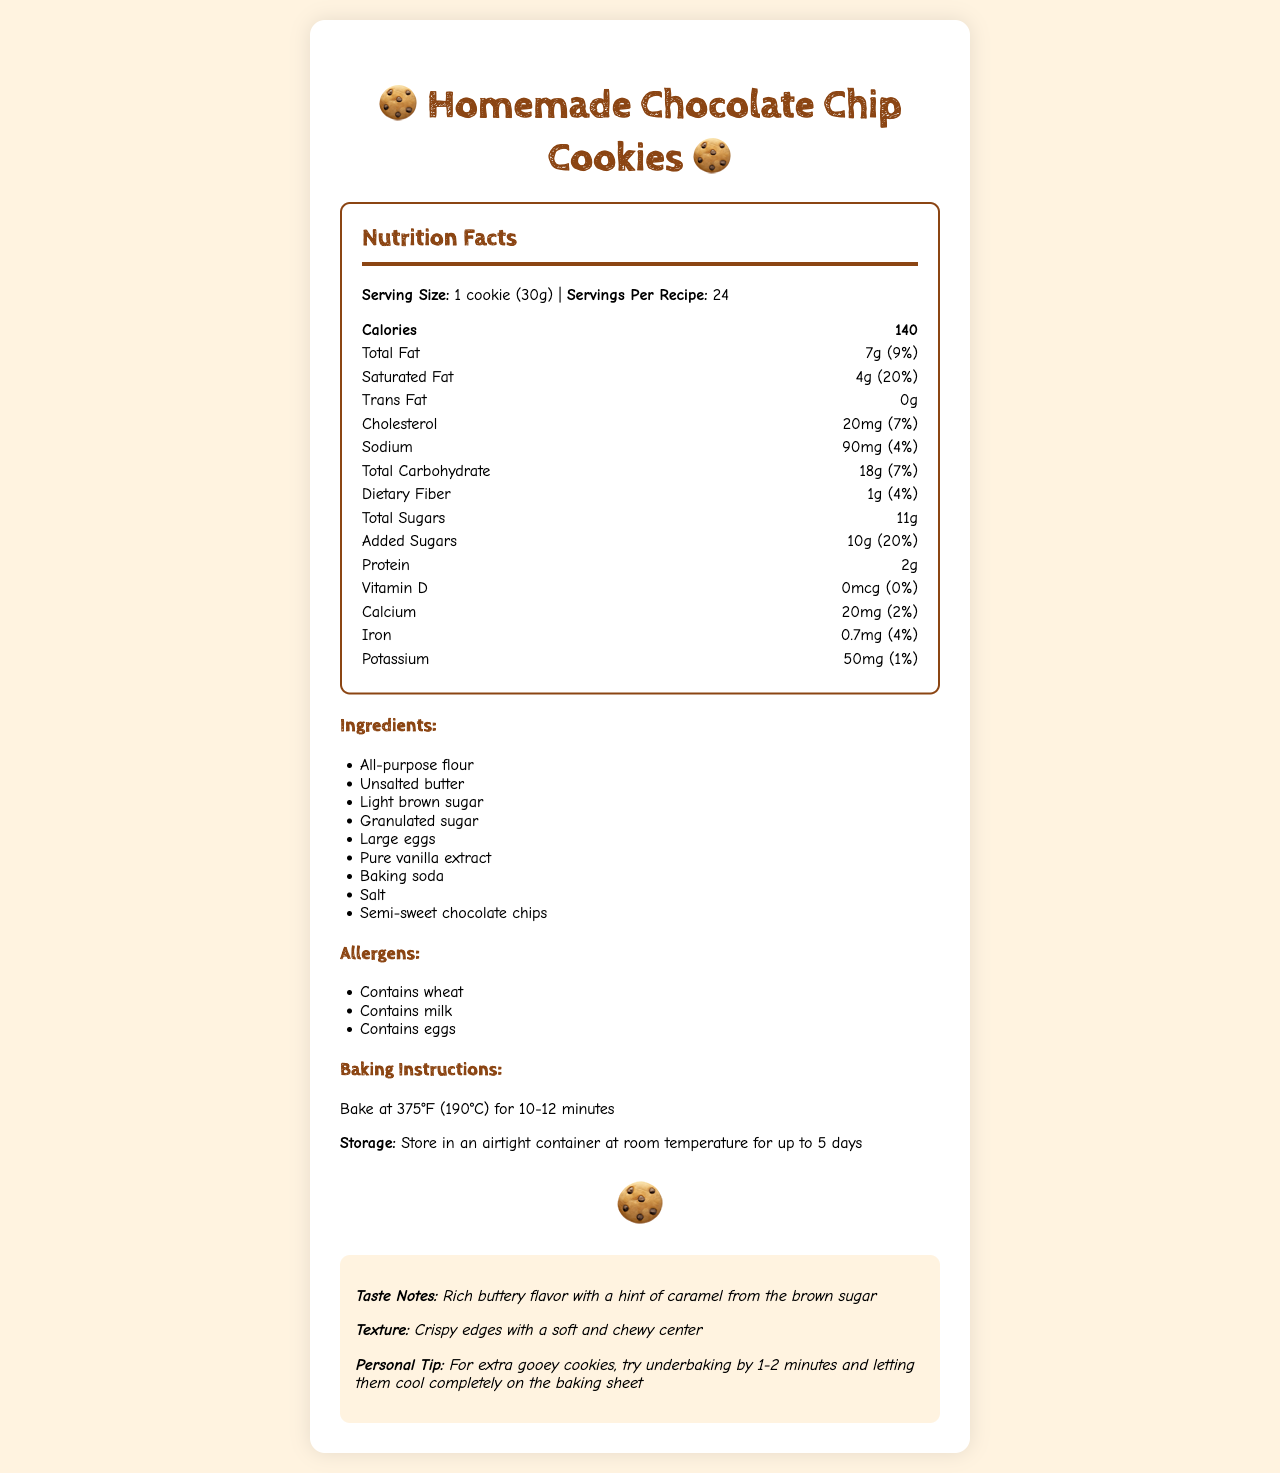what is the serving size? The serving size is specified at the beginning of the Nutrition Facts Label as "1 cookie (30g)".
Answer: 1 cookie (30g) how many calories are in each serving? The calories per serving are indicated at the top of the Nutrition Facts Label as "Calories 140".
Answer: 140 how much total fat is in one cookie? The total fat content is listed under the Nutrition Facts section as "Total Fat 7g (9%)".
Answer: 7g what is the amount of added sugars per serving? Added sugars are specified in the Nutrition Facts as "Added Sugars 10g (20%)".
Answer: 10g how much protein does one cookie have? The protein content is listed in the Nutrition Facts as "Protein 2g".
Answer: 2g what is the baking temperature for these cookies? The baking instructions mention to bake at "375°F (190°C)".
Answer: 375°F (190°C) how long should the cookies be baked? A. 8-10 minutes B. 10-12 minutes C. 12-14 minutes D. 14-16 minutes The baking instructions specify a bake time of "10-12 minutes".
Answer: B. 10-12 minutes what percent daily value of saturated fat does one cookie contain? A. 5% B. 10% C. 15% D. 20% The saturated fat content is stated as "Saturated Fat 4g (20%)" in the Nutrition Facts.
Answer: D. 20% does this recipe contain any eggs? The allergens section lists "Contains eggs".
Answer: Yes is there any trans fat in the cookies? The Nutrition Facts section clearly states "Trans Fat 0g".
Answer: No summarize the overall document in a few sentences. The document details various aspects of a chocolate chip cookie recipe, including nutritional information, ingredients, allergens, baking and storage instructions, and personal taste and texture notes.
Answer: The document provides the nutrition facts, ingredients, allergens, baking instructions, storage instructions, and personal notes for a homemade chocolate chip cookie recipe. Each cookie (30g) contains 140 calories, with notable nutrition contents including 7g of total fat, 11g total sugars, and 2g of protein. The recipe contains wheat, milk, and eggs. Baking instructions advise baking at 375°F (190°C) for 10-12 minutes, and cookies should be stored in an airtight container at room temperature for up to 5 days. The taste is described as rich and buttery with a hint of caramel, and the texture has crispy edges with a soft and chewy center. what is the source of vanilla extract used? The document does not specify any particular source or brand of the vanilla extract, only that it is "Pure vanilla extract".
Answer: Not enough information 